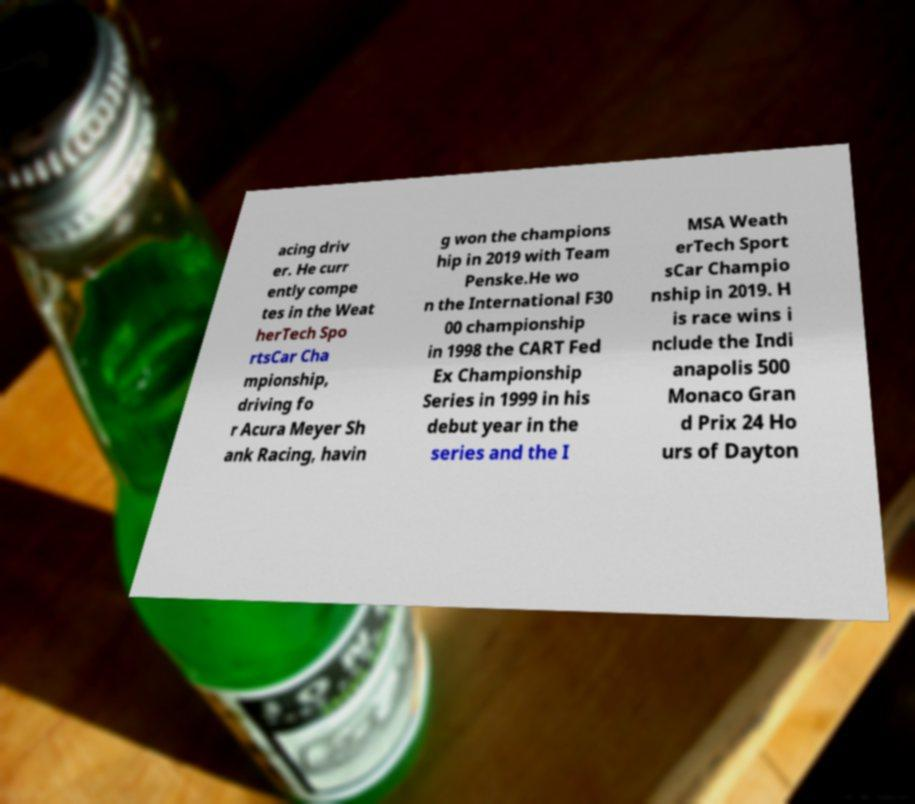I need the written content from this picture converted into text. Can you do that? acing driv er. He curr ently compe tes in the Weat herTech Spo rtsCar Cha mpionship, driving fo r Acura Meyer Sh ank Racing, havin g won the champions hip in 2019 with Team Penske.He wo n the International F30 00 championship in 1998 the CART Fed Ex Championship Series in 1999 in his debut year in the series and the I MSA Weath erTech Sport sCar Champio nship in 2019. H is race wins i nclude the Indi anapolis 500 Monaco Gran d Prix 24 Ho urs of Dayton 